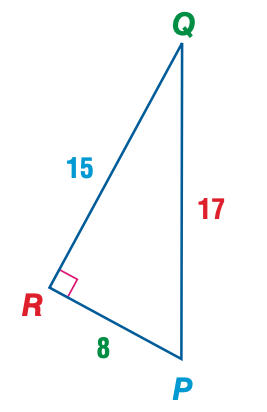Answer the mathemtical geometry problem and directly provide the correct option letter.
Question: Express the ratio of \sin Q as a decimal to the nearest hundredth.
Choices: A: 0.47 B: 0.53 C: 0.88 D: 1.88 A 